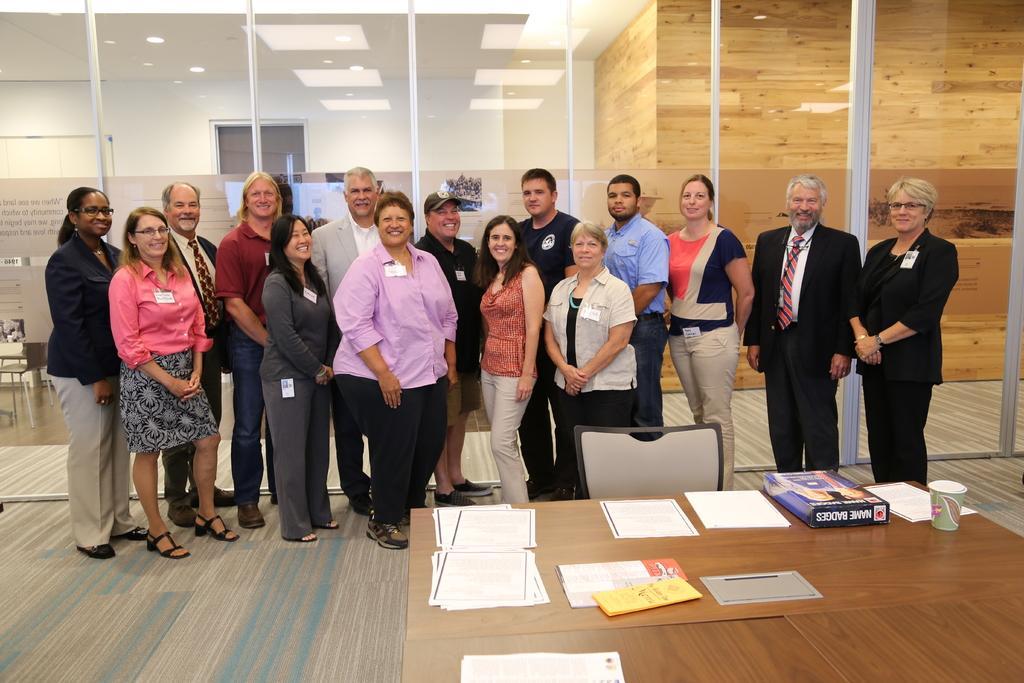Describe this image in one or two sentences. In this picture there are some people standing in front of the table on which there are some papers. 